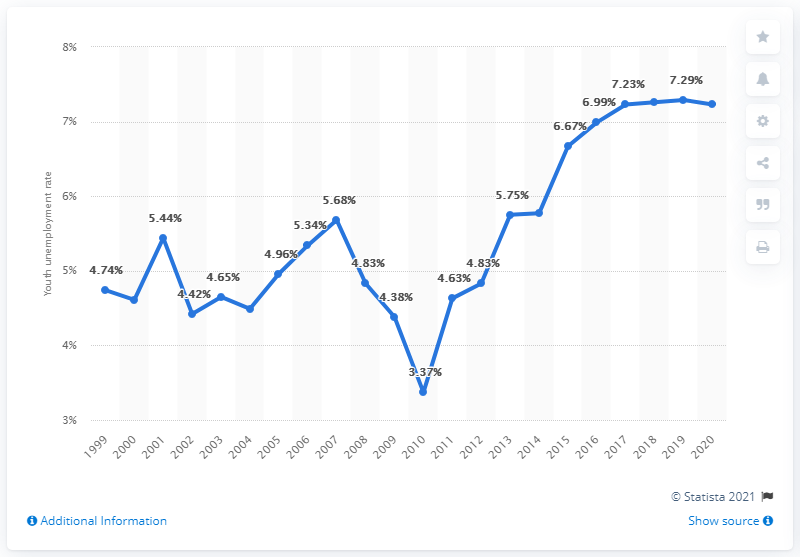Mention a couple of crucial points in this snapshot. In 2020, the youth unemployment rate in Vietnam was 7.23%. 